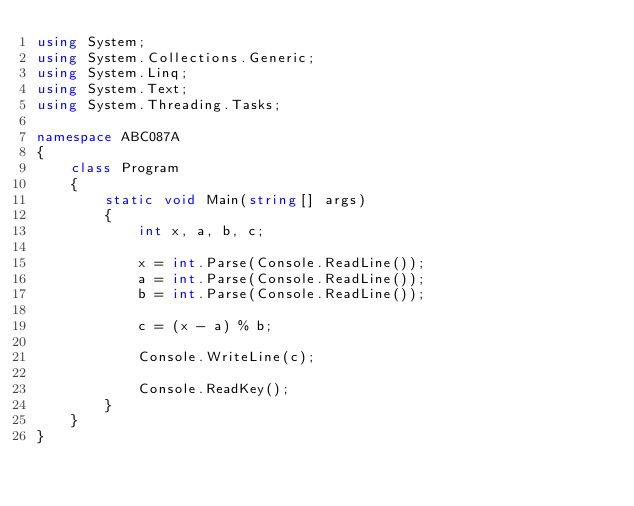<code> <loc_0><loc_0><loc_500><loc_500><_C#_>using System;
using System.Collections.Generic;
using System.Linq;
using System.Text;
using System.Threading.Tasks;

namespace ABC087A
{
    class Program
    {
        static void Main(string[] args)
        {
            int x, a, b, c;

            x = int.Parse(Console.ReadLine());
            a = int.Parse(Console.ReadLine());
            b = int.Parse(Console.ReadLine());

            c = (x - a) % b;

            Console.WriteLine(c);

            Console.ReadKey();
        }
    }
}
</code> 